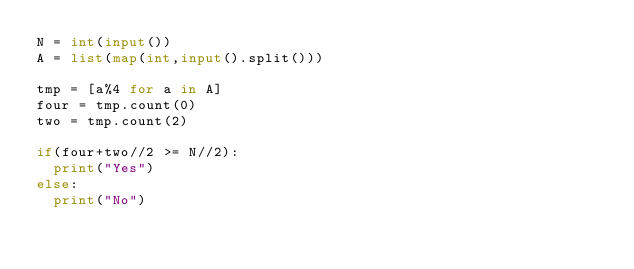<code> <loc_0><loc_0><loc_500><loc_500><_Python_>N = int(input())
A = list(map(int,input().split()))

tmp = [a%4 for a in A]
four = tmp.count(0)
two = tmp.count(2)

if(four+two//2 >= N//2):
  print("Yes")
else:
  print("No")</code> 